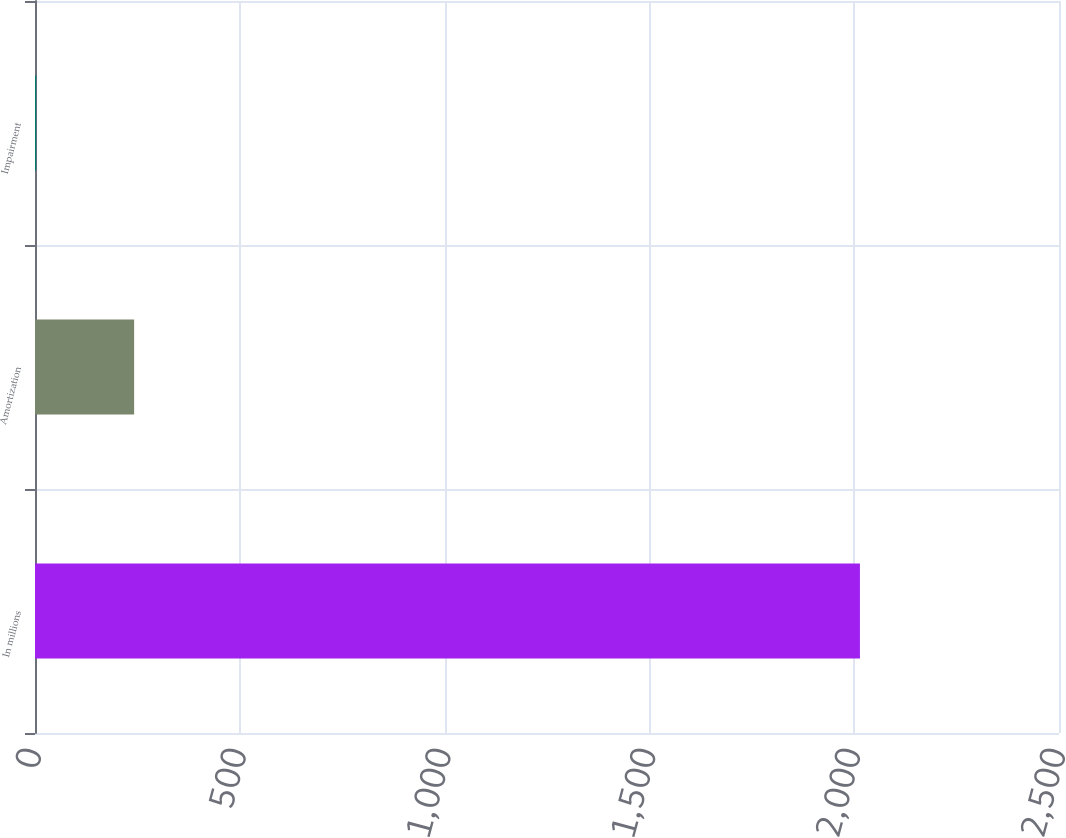Convert chart to OTSL. <chart><loc_0><loc_0><loc_500><loc_500><bar_chart><fcel>In millions<fcel>Amortization<fcel>Impairment<nl><fcel>2014<fcel>242<fcel>3<nl></chart> 